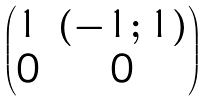Convert formula to latex. <formula><loc_0><loc_0><loc_500><loc_500>\begin{pmatrix} 1 & ( - 1 ; 1 ) \\ 0 & 0 \end{pmatrix}</formula> 